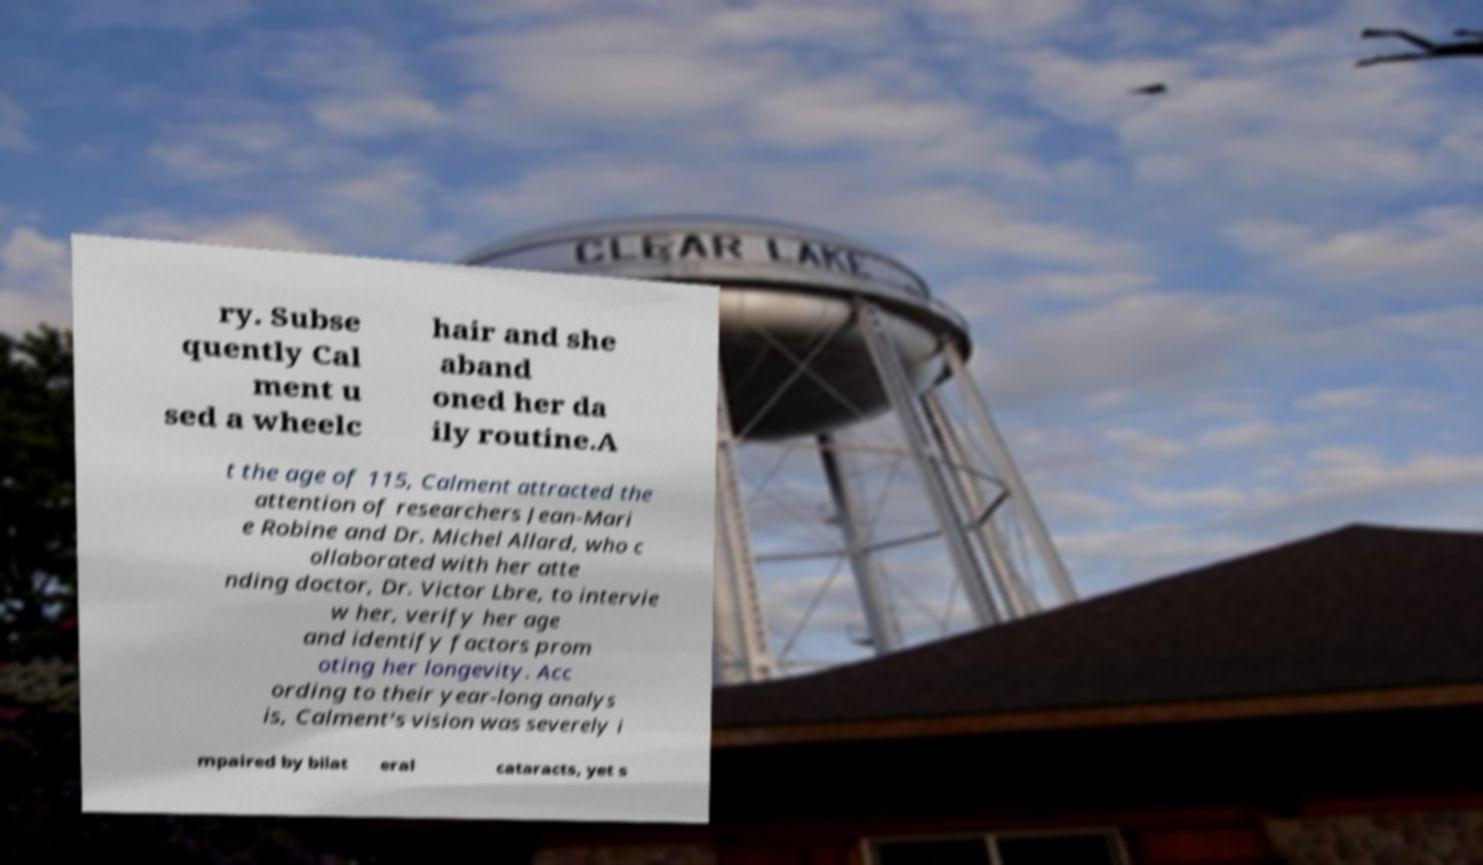Could you extract and type out the text from this image? ry. Subse quently Cal ment u sed a wheelc hair and she aband oned her da ily routine.A t the age of 115, Calment attracted the attention of researchers Jean-Mari e Robine and Dr. Michel Allard, who c ollaborated with her atte nding doctor, Dr. Victor Lbre, to intervie w her, verify her age and identify factors prom oting her longevity. Acc ording to their year-long analys is, Calment's vision was severely i mpaired by bilat eral cataracts, yet s 